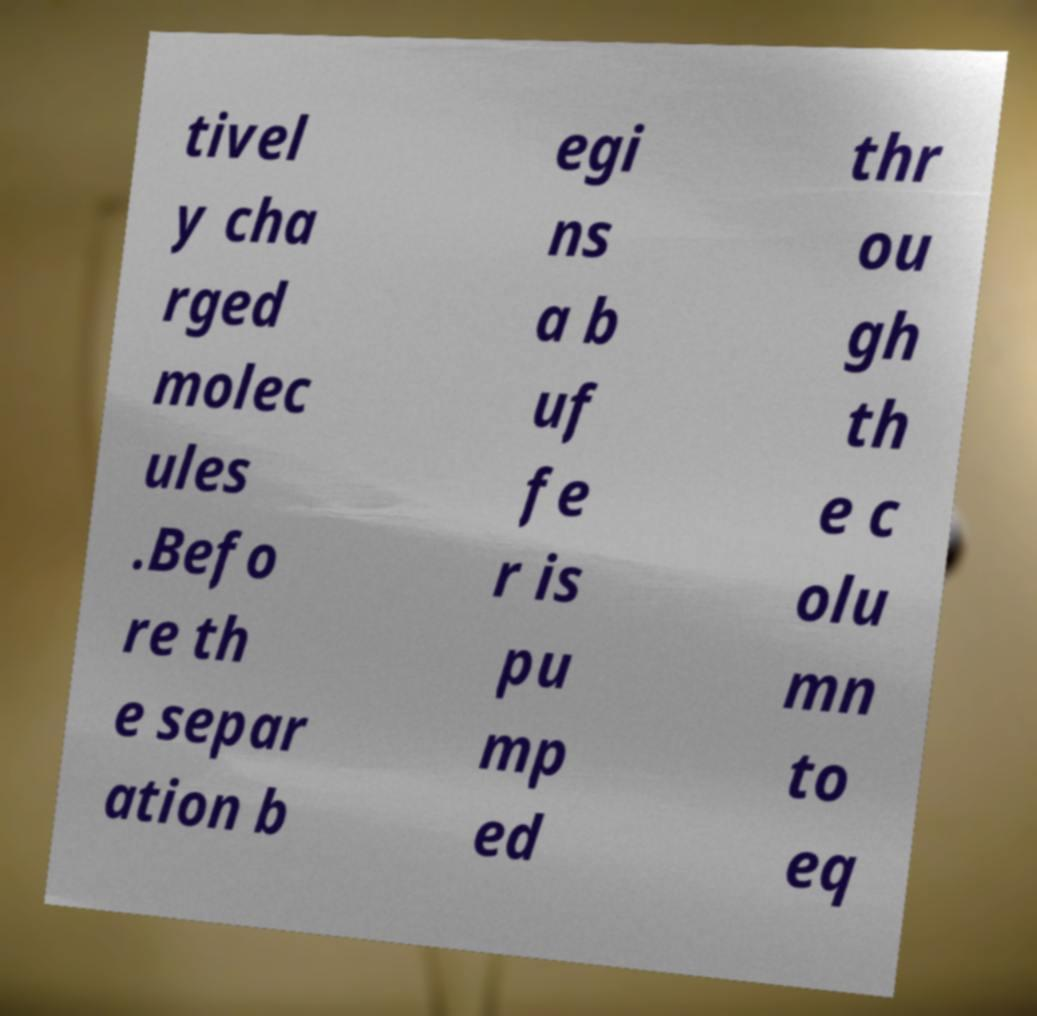For documentation purposes, I need the text within this image transcribed. Could you provide that? tivel y cha rged molec ules .Befo re th e separ ation b egi ns a b uf fe r is pu mp ed thr ou gh th e c olu mn to eq 